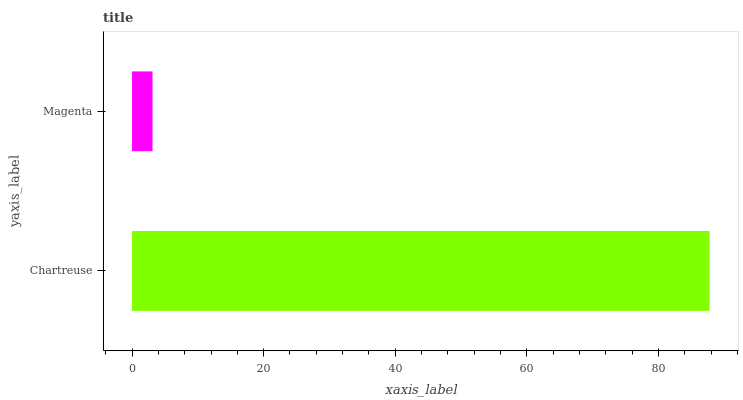Is Magenta the minimum?
Answer yes or no. Yes. Is Chartreuse the maximum?
Answer yes or no. Yes. Is Magenta the maximum?
Answer yes or no. No. Is Chartreuse greater than Magenta?
Answer yes or no. Yes. Is Magenta less than Chartreuse?
Answer yes or no. Yes. Is Magenta greater than Chartreuse?
Answer yes or no. No. Is Chartreuse less than Magenta?
Answer yes or no. No. Is Chartreuse the high median?
Answer yes or no. Yes. Is Magenta the low median?
Answer yes or no. Yes. Is Magenta the high median?
Answer yes or no. No. Is Chartreuse the low median?
Answer yes or no. No. 